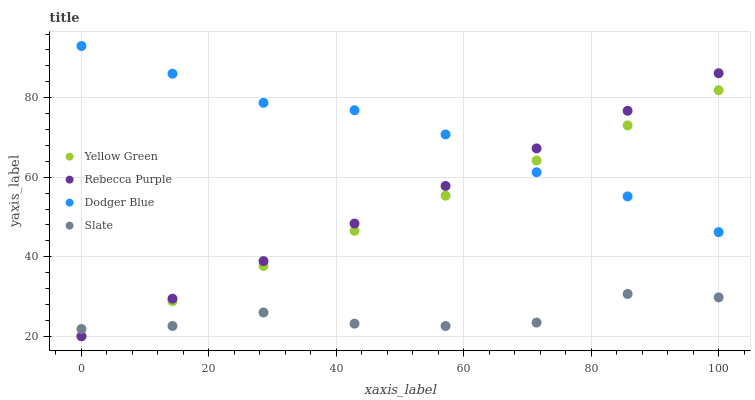Does Slate have the minimum area under the curve?
Answer yes or no. Yes. Does Dodger Blue have the maximum area under the curve?
Answer yes or no. Yes. Does Yellow Green have the minimum area under the curve?
Answer yes or no. No. Does Yellow Green have the maximum area under the curve?
Answer yes or no. No. Is Yellow Green the smoothest?
Answer yes or no. Yes. Is Slate the roughest?
Answer yes or no. Yes. Is Dodger Blue the smoothest?
Answer yes or no. No. Is Dodger Blue the roughest?
Answer yes or no. No. Does Yellow Green have the lowest value?
Answer yes or no. Yes. Does Dodger Blue have the lowest value?
Answer yes or no. No. Does Dodger Blue have the highest value?
Answer yes or no. Yes. Does Yellow Green have the highest value?
Answer yes or no. No. Is Slate less than Dodger Blue?
Answer yes or no. Yes. Is Dodger Blue greater than Slate?
Answer yes or no. Yes. Does Rebecca Purple intersect Yellow Green?
Answer yes or no. Yes. Is Rebecca Purple less than Yellow Green?
Answer yes or no. No. Is Rebecca Purple greater than Yellow Green?
Answer yes or no. No. Does Slate intersect Dodger Blue?
Answer yes or no. No. 